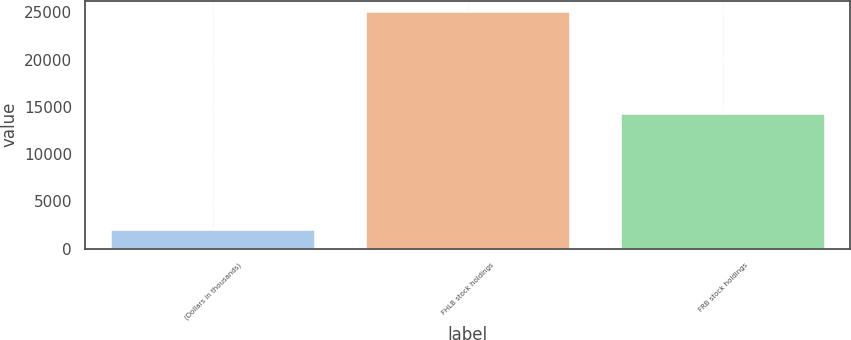<chart> <loc_0><loc_0><loc_500><loc_500><bar_chart><fcel>(Dollars in thousands)<fcel>FHLB stock holdings<fcel>FRB stock holdings<nl><fcel>2011<fcel>25000<fcel>14189<nl></chart> 